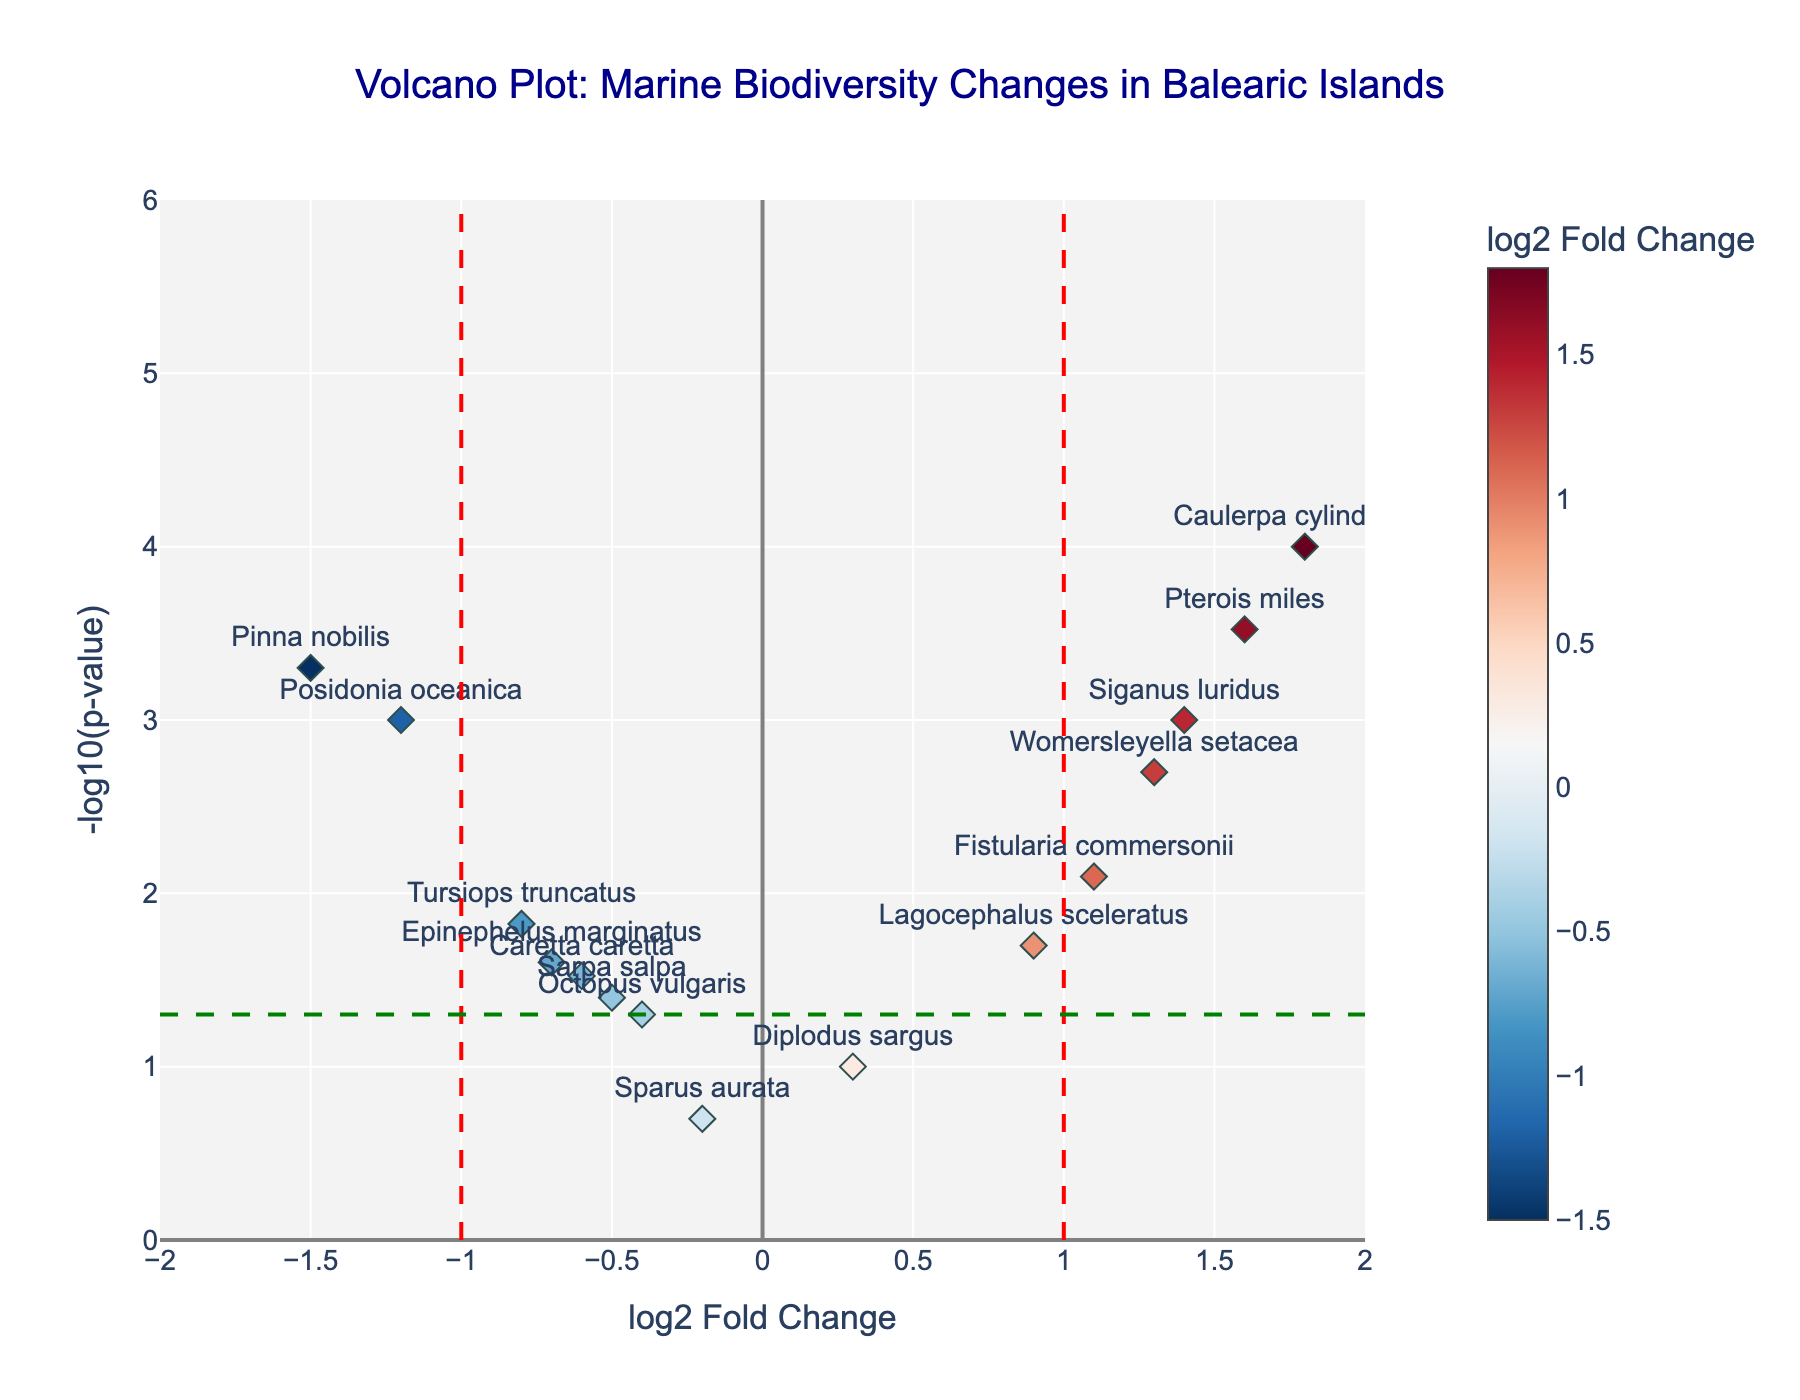Which species has the highest positive log2 fold change? To determine the species with the highest positive log2 fold change, look for the data point with the greatest log2FoldChange value on the x-axis. Pterois miles has the highest value at 1.6.
Answer: Pterois miles Which species has the lowest log2 fold change? The species with the lowest log2 fold change is identified by looking for the data point with the smallest log2FoldChange value. Pinna nobilis has the lowest value at -1.5.
Answer: Pinna nobilis How many species show a significant change (p-value < 0.05)? We count the number of data points above the green dashed line, which represents the significance threshold (-log10(p-value) = -log10(0.05) ≈ 1.301). There are 12 species above this threshold.
Answer: 12 What is the log2 fold change and p-value for Caulerpa cylindracea? Check the plot for the Caulerpa cylindracea data point and refer to its hover text. Its log2FoldChange is 1.8, and the p-value is 0.0001.
Answer: log2FoldChange: 1.8, p-value: 0.0001 Which species are considered invasive and have a positive log2 fold change? The species list includes Caulerpa cylindracea, Womersleyella setacea, Fistularia commersonii, Lagocephalus sceleratus, Pterois miles, and Siganus luridus, which are known invasive marine species. We check the plot to confirm these species have positive log2FoldChange values.
Answer: Caulerpa cylindracea, Womersleyella setacea, Fistularia commersonii, Lagocephalus sceleratus, Pterois miles, Siganus luridus Which native species has the highest negative log2 fold change? Focus on native species (e.g., Posidonia oceanica, Tursiops truncatus). The one with the most negative log2FoldChange is Posidonia oceanica with a value of -1.2.
Answer: Posidonia oceanica What is the median -log10(p-value) of the native species? Identify -log10(p-value) for all native species: Posidonia oceanica (3.0), Tursiops truncatus (1.82), Pinna nobilis (3.3), Caretta caretta (1.52), Diplodus sargus (1.0), Sparus aurata (0.7), Octopus vulgaris (1.3), Sarpa salpa (1.4), Epinephelus marginatus (1.6). The median is the middle value when sorted: (0.7, 1.0, 1.3, 1.4, 1.52, 1.6, 1.82, 3.0, 3.3). Median is 1.52.
Answer: 1.52 Which species has the lowest p-value? The species with the lowest p-value is identified by finding the highest -log10(p-value) value on the y-axis. Caulerpa cylindracea has the lowest p-value at 0.0001.
Answer: Caulerpa cylindracea How many species have a log2 fold change between -0.5 and 0.5? Count the data points that lie within the range of -0.5 to 0.5 on the x-axis. These species are Diplodus sargus (0.3) and Sparus aurata (-0.2).
Answer: 2 Is there any species with a log2 fold change of exactly 0? Scan the plot for any data points that fall on the vertical line at log2FoldChange = 0. There are no data points on this line.
Answer: No 